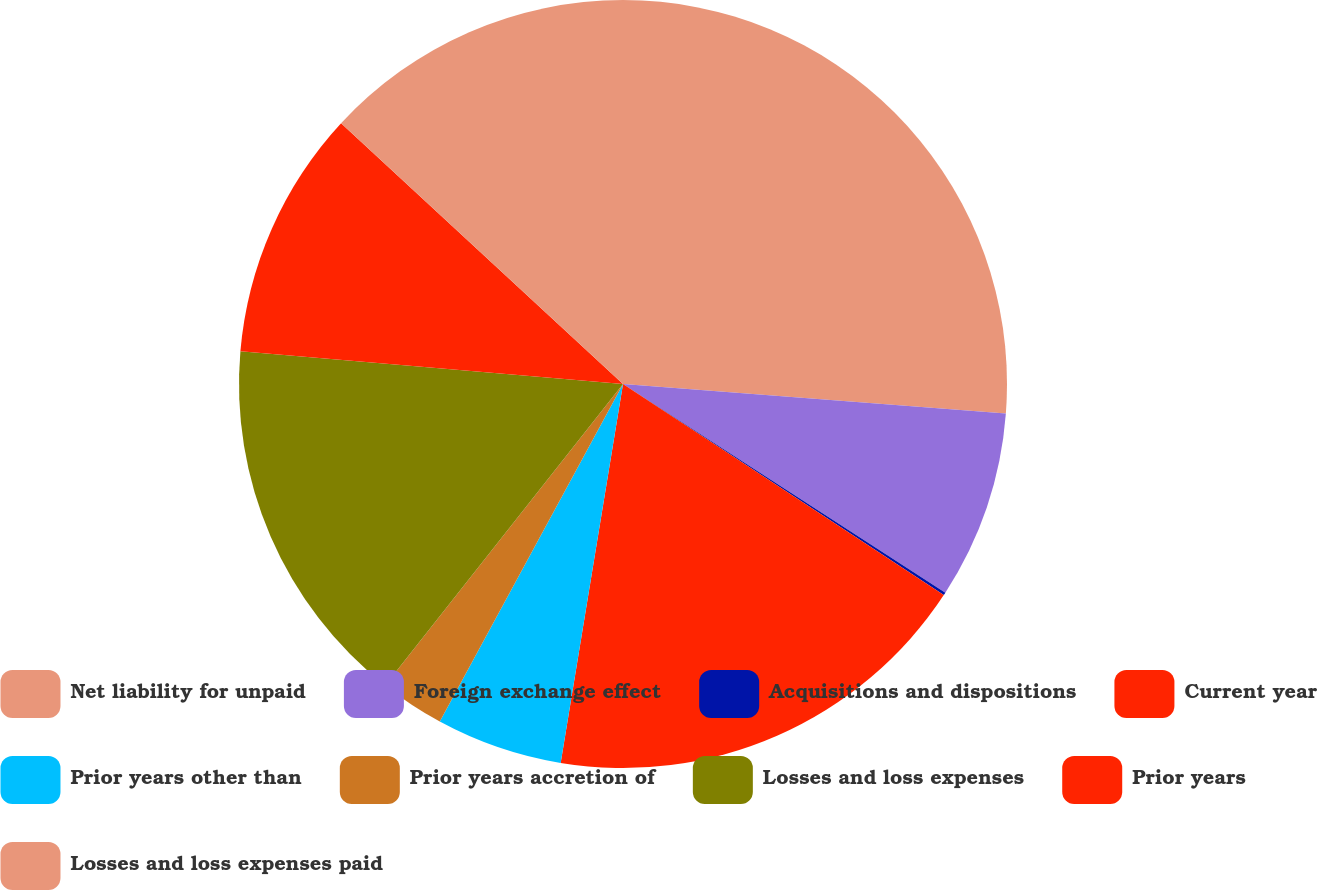Convert chart to OTSL. <chart><loc_0><loc_0><loc_500><loc_500><pie_chart><fcel>Net liability for unpaid<fcel>Foreign exchange effect<fcel>Acquisitions and dispositions<fcel>Current year<fcel>Prior years other than<fcel>Prior years accretion of<fcel>Losses and loss expenses<fcel>Prior years<fcel>Losses and loss expenses paid<nl><fcel>26.22%<fcel>7.92%<fcel>0.12%<fcel>18.33%<fcel>5.32%<fcel>2.72%<fcel>15.72%<fcel>10.52%<fcel>13.12%<nl></chart> 